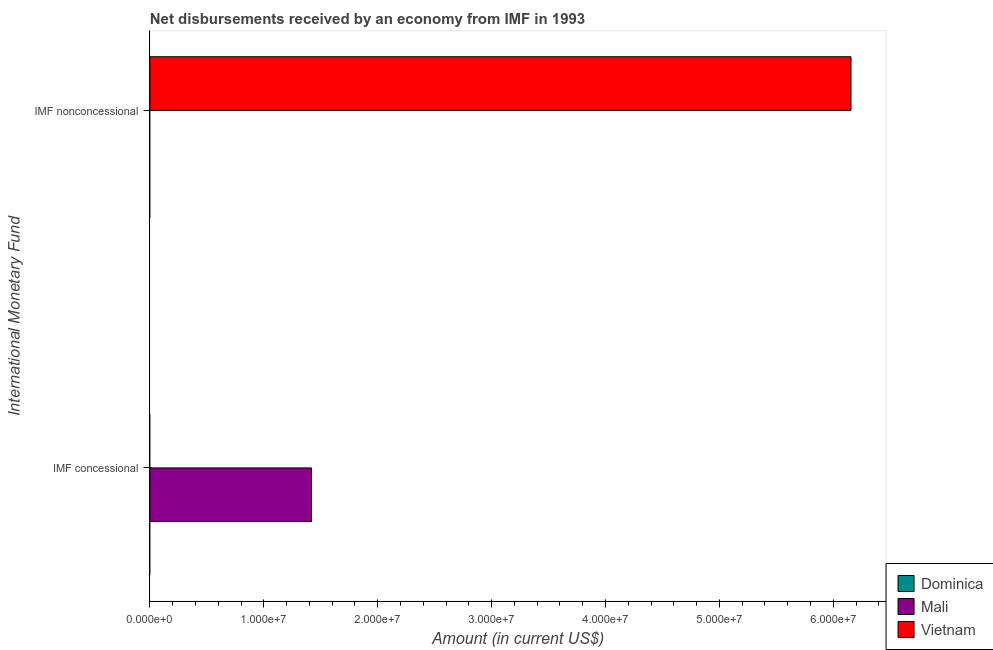Are the number of bars per tick equal to the number of legend labels?
Make the answer very short. No. What is the label of the 1st group of bars from the top?
Your answer should be compact. IMF nonconcessional. Across all countries, what is the maximum net non concessional disbursements from imf?
Ensure brevity in your answer.  6.16e+07. Across all countries, what is the minimum net concessional disbursements from imf?
Your response must be concise. 0. In which country was the net non concessional disbursements from imf maximum?
Offer a very short reply. Vietnam. What is the total net concessional disbursements from imf in the graph?
Ensure brevity in your answer.  1.42e+07. What is the average net concessional disbursements from imf per country?
Offer a very short reply. 4.73e+06. How many bars are there?
Offer a very short reply. 2. Are all the bars in the graph horizontal?
Give a very brief answer. Yes. How many countries are there in the graph?
Ensure brevity in your answer.  3. What is the difference between two consecutive major ticks on the X-axis?
Offer a terse response. 1.00e+07. Does the graph contain any zero values?
Your answer should be compact. Yes. Where does the legend appear in the graph?
Offer a very short reply. Bottom right. How are the legend labels stacked?
Provide a short and direct response. Vertical. What is the title of the graph?
Make the answer very short. Net disbursements received by an economy from IMF in 1993. Does "Angola" appear as one of the legend labels in the graph?
Provide a short and direct response. No. What is the label or title of the Y-axis?
Provide a succinct answer. International Monetary Fund. What is the Amount (in current US$) in Dominica in IMF concessional?
Your response must be concise. 0. What is the Amount (in current US$) in Mali in IMF concessional?
Your answer should be compact. 1.42e+07. What is the Amount (in current US$) in Vietnam in IMF nonconcessional?
Offer a terse response. 6.16e+07. Across all International Monetary Fund, what is the maximum Amount (in current US$) of Mali?
Your answer should be very brief. 1.42e+07. Across all International Monetary Fund, what is the maximum Amount (in current US$) of Vietnam?
Your answer should be very brief. 6.16e+07. Across all International Monetary Fund, what is the minimum Amount (in current US$) in Mali?
Your answer should be very brief. 0. Across all International Monetary Fund, what is the minimum Amount (in current US$) in Vietnam?
Provide a succinct answer. 0. What is the total Amount (in current US$) in Mali in the graph?
Provide a succinct answer. 1.42e+07. What is the total Amount (in current US$) of Vietnam in the graph?
Provide a succinct answer. 6.16e+07. What is the difference between the Amount (in current US$) in Mali in IMF concessional and the Amount (in current US$) in Vietnam in IMF nonconcessional?
Offer a very short reply. -4.74e+07. What is the average Amount (in current US$) in Mali per International Monetary Fund?
Make the answer very short. 7.09e+06. What is the average Amount (in current US$) of Vietnam per International Monetary Fund?
Ensure brevity in your answer.  3.08e+07. What is the difference between the highest and the lowest Amount (in current US$) in Mali?
Provide a succinct answer. 1.42e+07. What is the difference between the highest and the lowest Amount (in current US$) in Vietnam?
Your answer should be compact. 6.16e+07. 